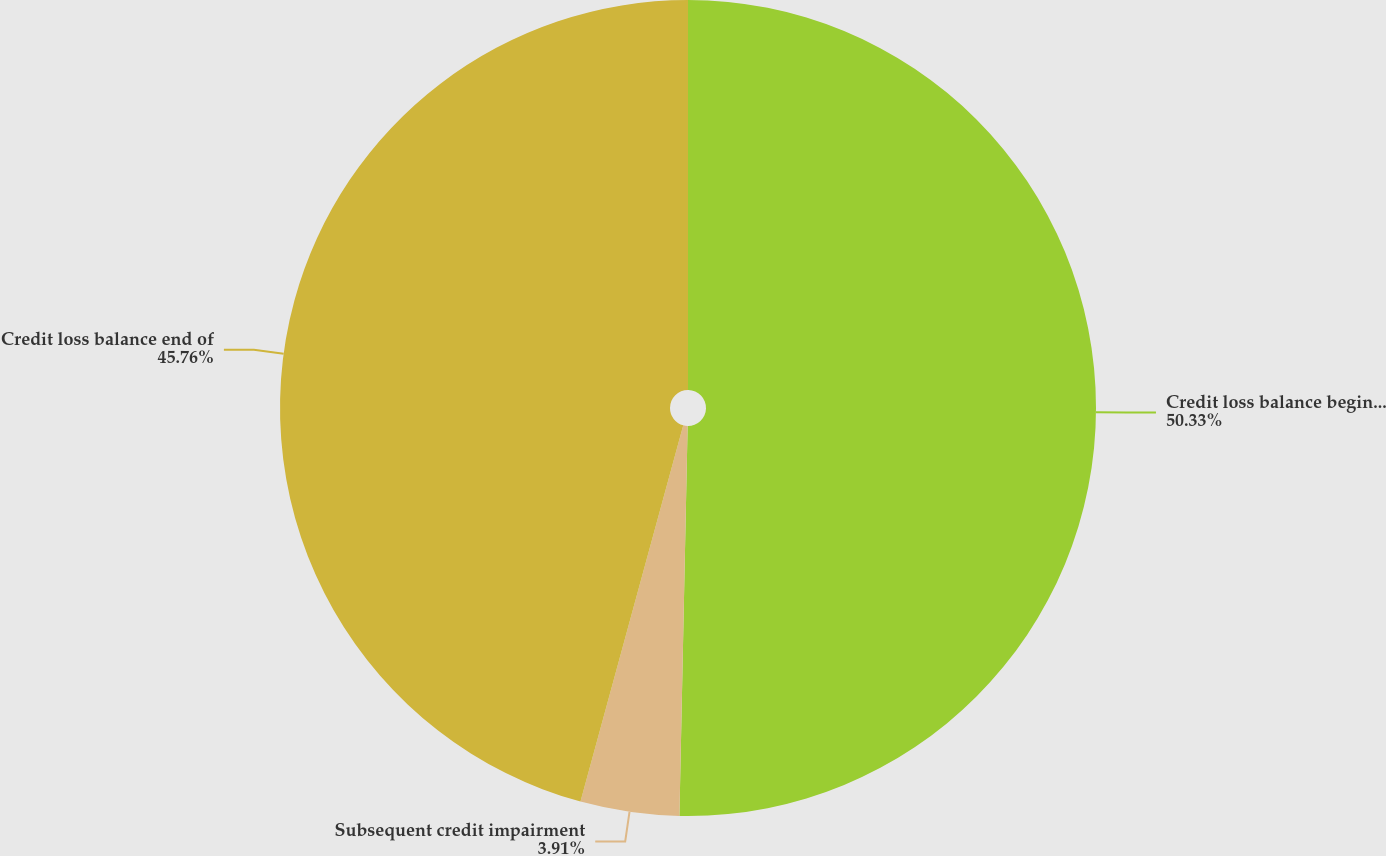Convert chart to OTSL. <chart><loc_0><loc_0><loc_500><loc_500><pie_chart><fcel>Credit loss balance beginning<fcel>Subsequent credit impairment<fcel>Credit loss balance end of<nl><fcel>50.34%<fcel>3.91%<fcel>45.76%<nl></chart> 